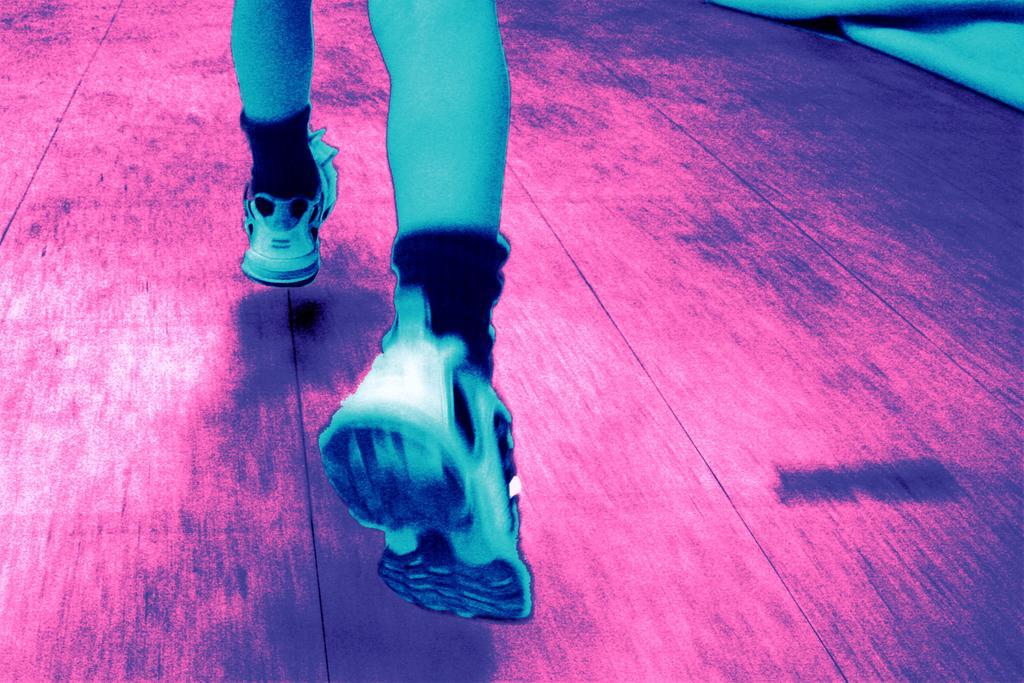Please provide a concise description of this image. This is an edited picture. In this image there is a person running. At the bottom there is a floor. At the top right it looks like a cloth. 